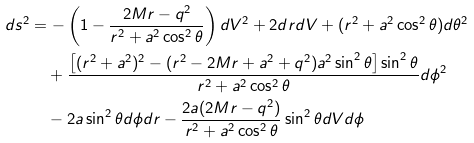<formula> <loc_0><loc_0><loc_500><loc_500>d s ^ { 2 } & = - \left ( 1 - \frac { 2 M r - q ^ { 2 } } { r ^ { 2 } + a ^ { 2 } \cos ^ { 2 } \theta } \right ) d V ^ { 2 } + 2 d r d V + ( r ^ { 2 } + a ^ { 2 } \cos ^ { 2 } \theta ) d \theta ^ { 2 } \\ & \quad + \frac { \left [ ( r ^ { 2 } + a ^ { 2 } ) ^ { 2 } - ( r ^ { 2 } - 2 M r + a ^ { 2 } + q ^ { 2 } ) a ^ { 2 } \sin ^ { 2 } \theta \right ] \sin ^ { 2 } \theta } { r ^ { 2 } + a ^ { 2 } \cos ^ { 2 } \theta } d \phi ^ { 2 } \\ & \quad - 2 a \sin ^ { 2 } \theta d \phi d r - \frac { 2 a ( 2 M r - q ^ { 2 } ) } { r ^ { 2 } + a ^ { 2 } \cos ^ { 2 } \theta } \sin ^ { 2 } \theta d V d \phi</formula> 